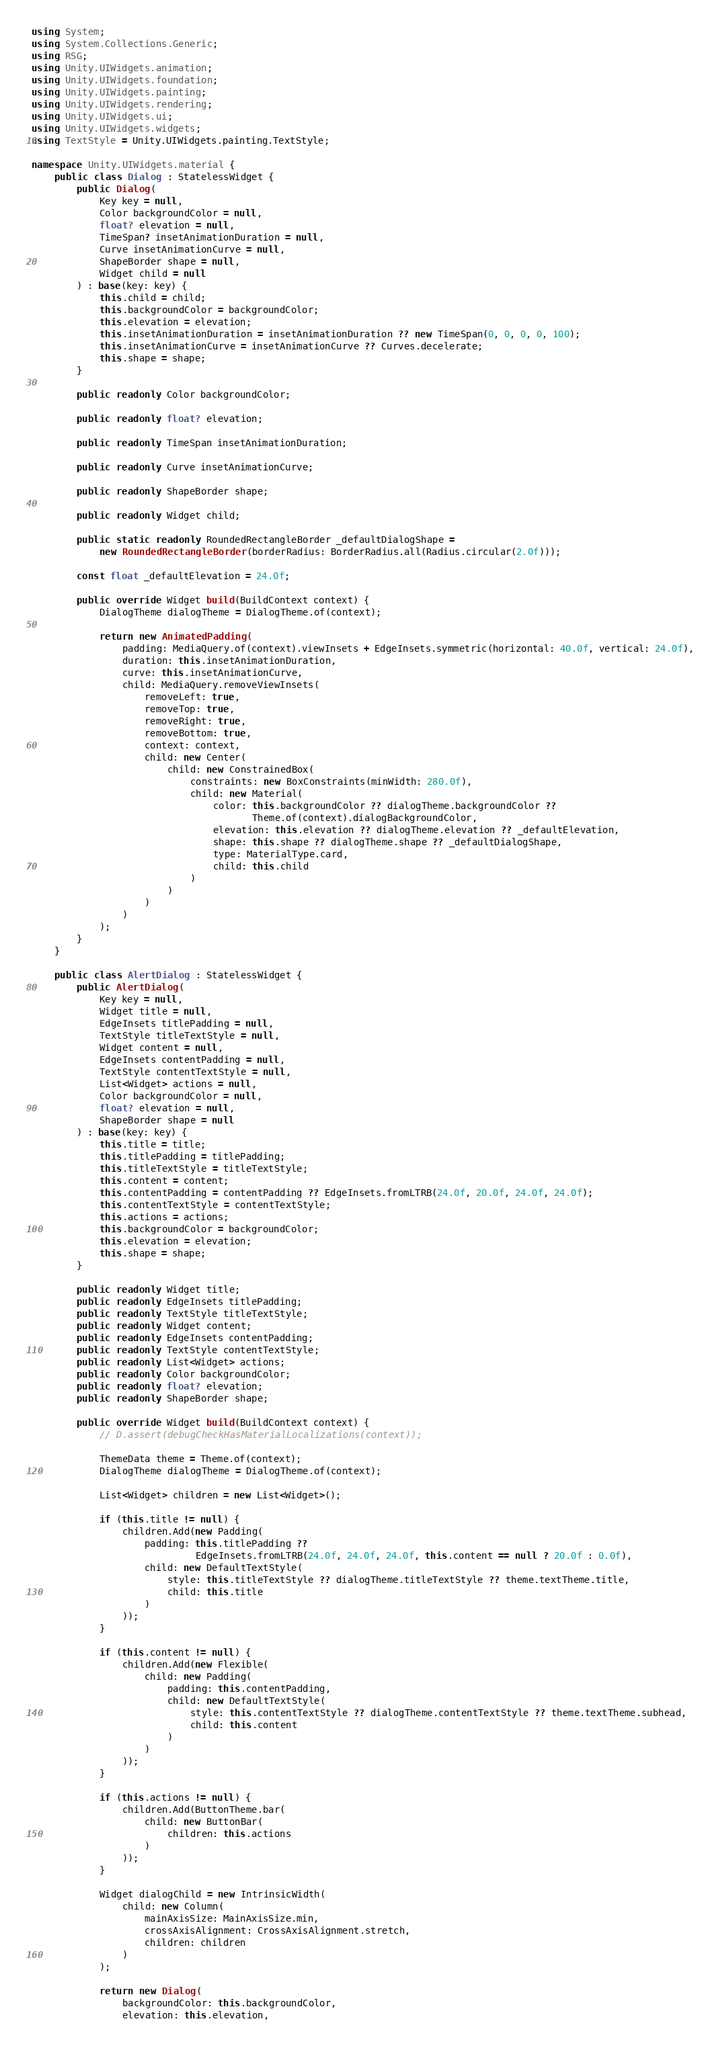Convert code to text. <code><loc_0><loc_0><loc_500><loc_500><_C#_>using System;
using System.Collections.Generic;
using RSG;
using Unity.UIWidgets.animation;
using Unity.UIWidgets.foundation;
using Unity.UIWidgets.painting;
using Unity.UIWidgets.rendering;
using Unity.UIWidgets.ui;
using Unity.UIWidgets.widgets;
using TextStyle = Unity.UIWidgets.painting.TextStyle;

namespace Unity.UIWidgets.material {
    public class Dialog : StatelessWidget {
        public Dialog(
            Key key = null,
            Color backgroundColor = null,
            float? elevation = null,
            TimeSpan? insetAnimationDuration = null,
            Curve insetAnimationCurve = null,
            ShapeBorder shape = null,
            Widget child = null
        ) : base(key: key) {
            this.child = child;
            this.backgroundColor = backgroundColor;
            this.elevation = elevation;
            this.insetAnimationDuration = insetAnimationDuration ?? new TimeSpan(0, 0, 0, 0, 100);
            this.insetAnimationCurve = insetAnimationCurve ?? Curves.decelerate;
            this.shape = shape;
        }

        public readonly Color backgroundColor;

        public readonly float? elevation;

        public readonly TimeSpan insetAnimationDuration;

        public readonly Curve insetAnimationCurve;

        public readonly ShapeBorder shape;

        public readonly Widget child;

        public static readonly RoundedRectangleBorder _defaultDialogShape =
            new RoundedRectangleBorder(borderRadius: BorderRadius.all(Radius.circular(2.0f)));

        const float _defaultElevation = 24.0f;

        public override Widget build(BuildContext context) {
            DialogTheme dialogTheme = DialogTheme.of(context);

            return new AnimatedPadding(
                padding: MediaQuery.of(context).viewInsets + EdgeInsets.symmetric(horizontal: 40.0f, vertical: 24.0f),
                duration: this.insetAnimationDuration,
                curve: this.insetAnimationCurve,
                child: MediaQuery.removeViewInsets(
                    removeLeft: true,
                    removeTop: true,
                    removeRight: true,
                    removeBottom: true,
                    context: context,
                    child: new Center(
                        child: new ConstrainedBox(
                            constraints: new BoxConstraints(minWidth: 280.0f),
                            child: new Material(
                                color: this.backgroundColor ?? dialogTheme.backgroundColor ??
                                       Theme.of(context).dialogBackgroundColor,
                                elevation: this.elevation ?? dialogTheme.elevation ?? _defaultElevation,
                                shape: this.shape ?? dialogTheme.shape ?? _defaultDialogShape,
                                type: MaterialType.card,
                                child: this.child
                            )
                        )
                    )
                )
            );
        }
    }

    public class AlertDialog : StatelessWidget {
        public AlertDialog(
            Key key = null,
            Widget title = null,
            EdgeInsets titlePadding = null,
            TextStyle titleTextStyle = null,
            Widget content = null,
            EdgeInsets contentPadding = null,
            TextStyle contentTextStyle = null,
            List<Widget> actions = null,
            Color backgroundColor = null,
            float? elevation = null,
            ShapeBorder shape = null
        ) : base(key: key) {
            this.title = title;
            this.titlePadding = titlePadding;
            this.titleTextStyle = titleTextStyle;
            this.content = content;
            this.contentPadding = contentPadding ?? EdgeInsets.fromLTRB(24.0f, 20.0f, 24.0f, 24.0f);
            this.contentTextStyle = contentTextStyle;
            this.actions = actions;
            this.backgroundColor = backgroundColor;
            this.elevation = elevation;
            this.shape = shape;
        }

        public readonly Widget title;
        public readonly EdgeInsets titlePadding;
        public readonly TextStyle titleTextStyle;
        public readonly Widget content;
        public readonly EdgeInsets contentPadding;
        public readonly TextStyle contentTextStyle;
        public readonly List<Widget> actions;
        public readonly Color backgroundColor;
        public readonly float? elevation;
        public readonly ShapeBorder shape;

        public override Widget build(BuildContext context) {
            // D.assert(debugCheckHasMaterialLocalizations(context));

            ThemeData theme = Theme.of(context);
            DialogTheme dialogTheme = DialogTheme.of(context);

            List<Widget> children = new List<Widget>();

            if (this.title != null) {
                children.Add(new Padding(
                    padding: this.titlePadding ??
                             EdgeInsets.fromLTRB(24.0f, 24.0f, 24.0f, this.content == null ? 20.0f : 0.0f),
                    child: new DefaultTextStyle(
                        style: this.titleTextStyle ?? dialogTheme.titleTextStyle ?? theme.textTheme.title,
                        child: this.title
                    )
                ));
            }

            if (this.content != null) {
                children.Add(new Flexible(
                    child: new Padding(
                        padding: this.contentPadding,
                        child: new DefaultTextStyle(
                            style: this.contentTextStyle ?? dialogTheme.contentTextStyle ?? theme.textTheme.subhead,
                            child: this.content
                        )
                    )
                ));
            }

            if (this.actions != null) {
                children.Add(ButtonTheme.bar(
                    child: new ButtonBar(
                        children: this.actions
                    )
                ));
            }

            Widget dialogChild = new IntrinsicWidth(
                child: new Column(
                    mainAxisSize: MainAxisSize.min,
                    crossAxisAlignment: CrossAxisAlignment.stretch,
                    children: children
                )
            );

            return new Dialog(
                backgroundColor: this.backgroundColor,
                elevation: this.elevation,</code> 